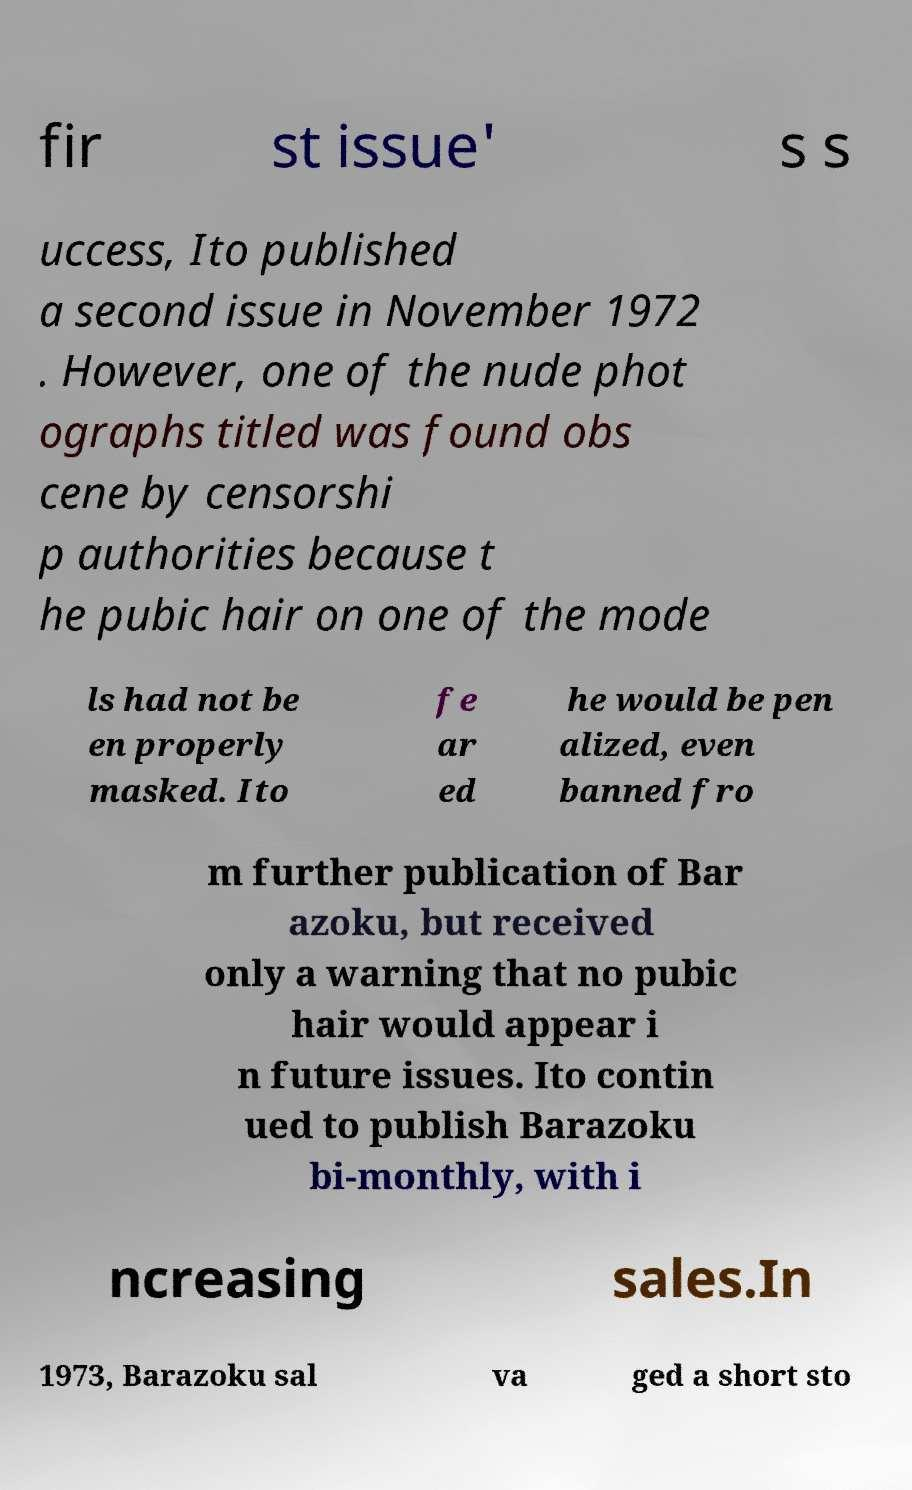For documentation purposes, I need the text within this image transcribed. Could you provide that? fir st issue' s s uccess, Ito published a second issue in November 1972 . However, one of the nude phot ographs titled was found obs cene by censorshi p authorities because t he pubic hair on one of the mode ls had not be en properly masked. Ito fe ar ed he would be pen alized, even banned fro m further publication of Bar azoku, but received only a warning that no pubic hair would appear i n future issues. Ito contin ued to publish Barazoku bi-monthly, with i ncreasing sales.In 1973, Barazoku sal va ged a short sto 